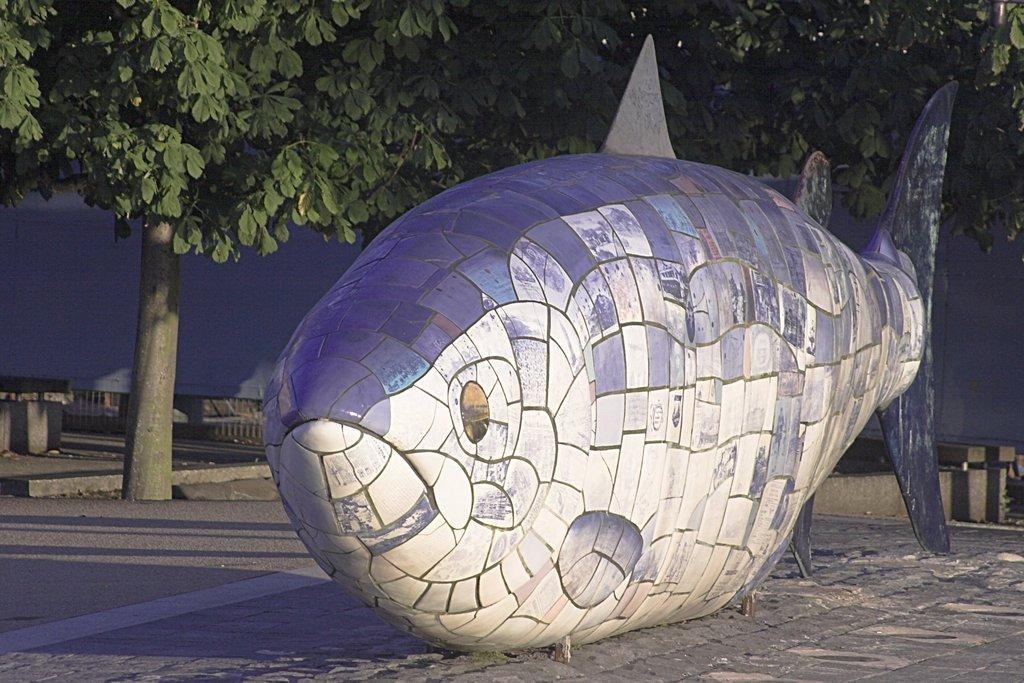What is the main subject in the center of the image? There is a sculpture in the center of the image. What can be seen in the background of the image? There are trees and a fence visible in the background of the image. What type of stamp can be seen on the sculpture in the image? There is no stamp present on the sculpture in the image. 